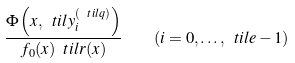Convert formula to latex. <formula><loc_0><loc_0><loc_500><loc_500>\frac { \Phi \left ( x , \ t i l y ^ { ( \ t i l q ) } _ { i } \right ) } { f _ { 0 } ( x ) \ t i l r ( x ) } \quad ( i = 0 , \dots , \ t i l e - 1 )</formula> 